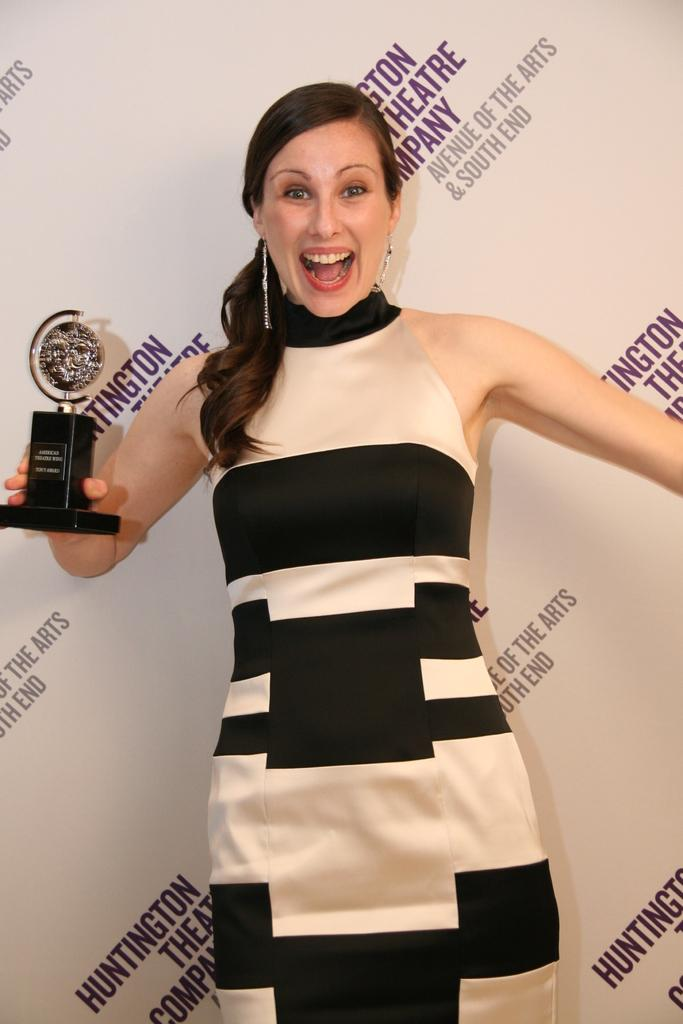<image>
Summarize the visual content of the image. A woman holds an award in front of a backdrop that says Huntington Theatre Company on it. 